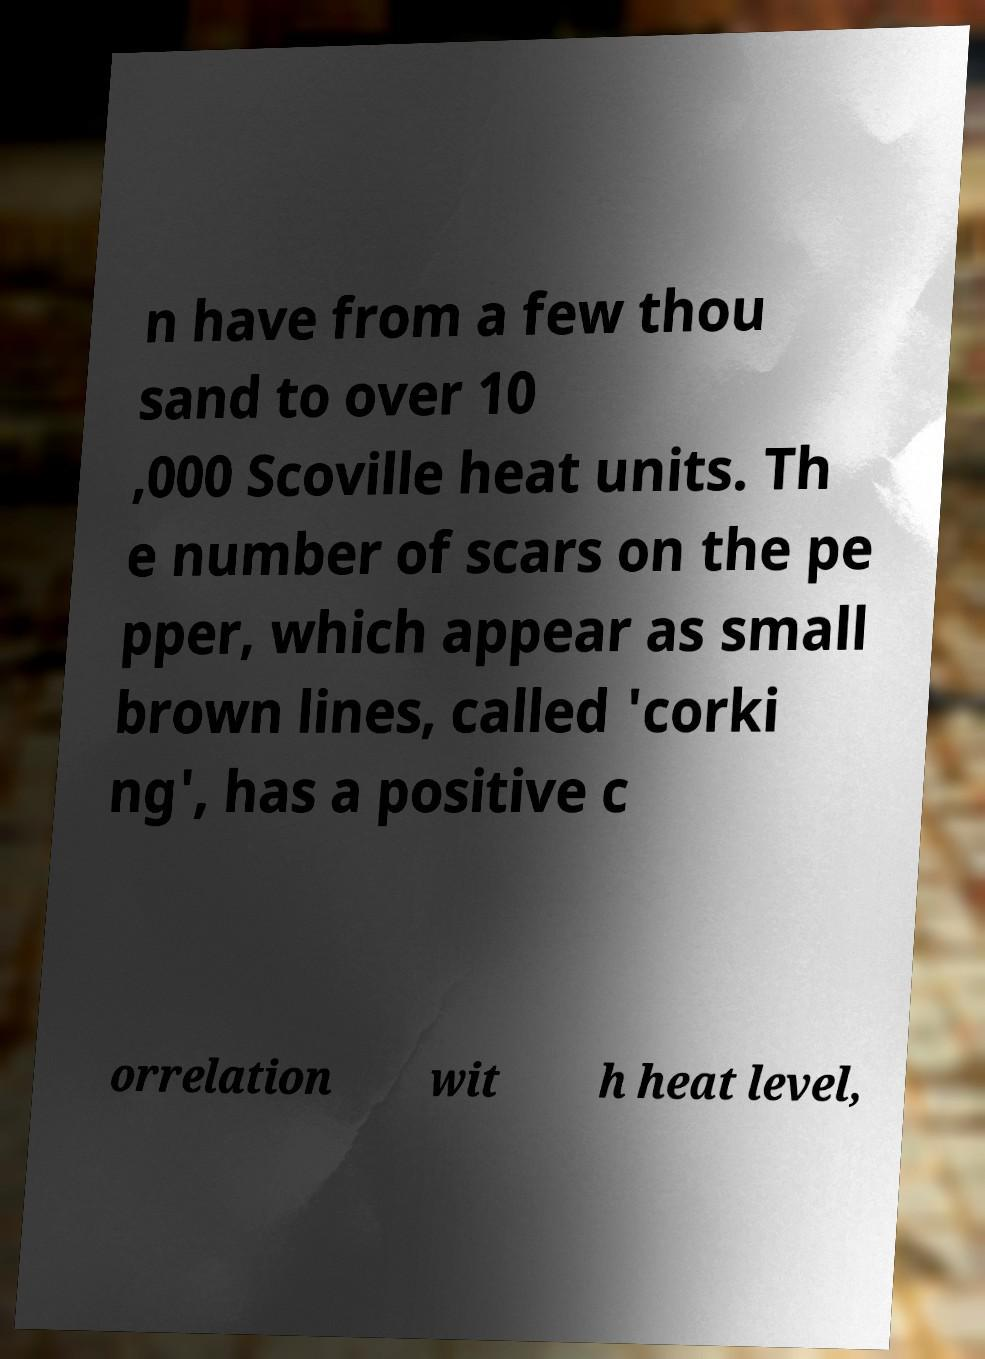Could you extract and type out the text from this image? n have from a few thou sand to over 10 ,000 Scoville heat units. Th e number of scars on the pe pper, which appear as small brown lines, called 'corki ng', has a positive c orrelation wit h heat level, 